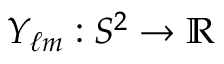Convert formula to latex. <formula><loc_0><loc_0><loc_500><loc_500>Y _ { \ell m } \colon S ^ { 2 } \to \mathbb { R }</formula> 